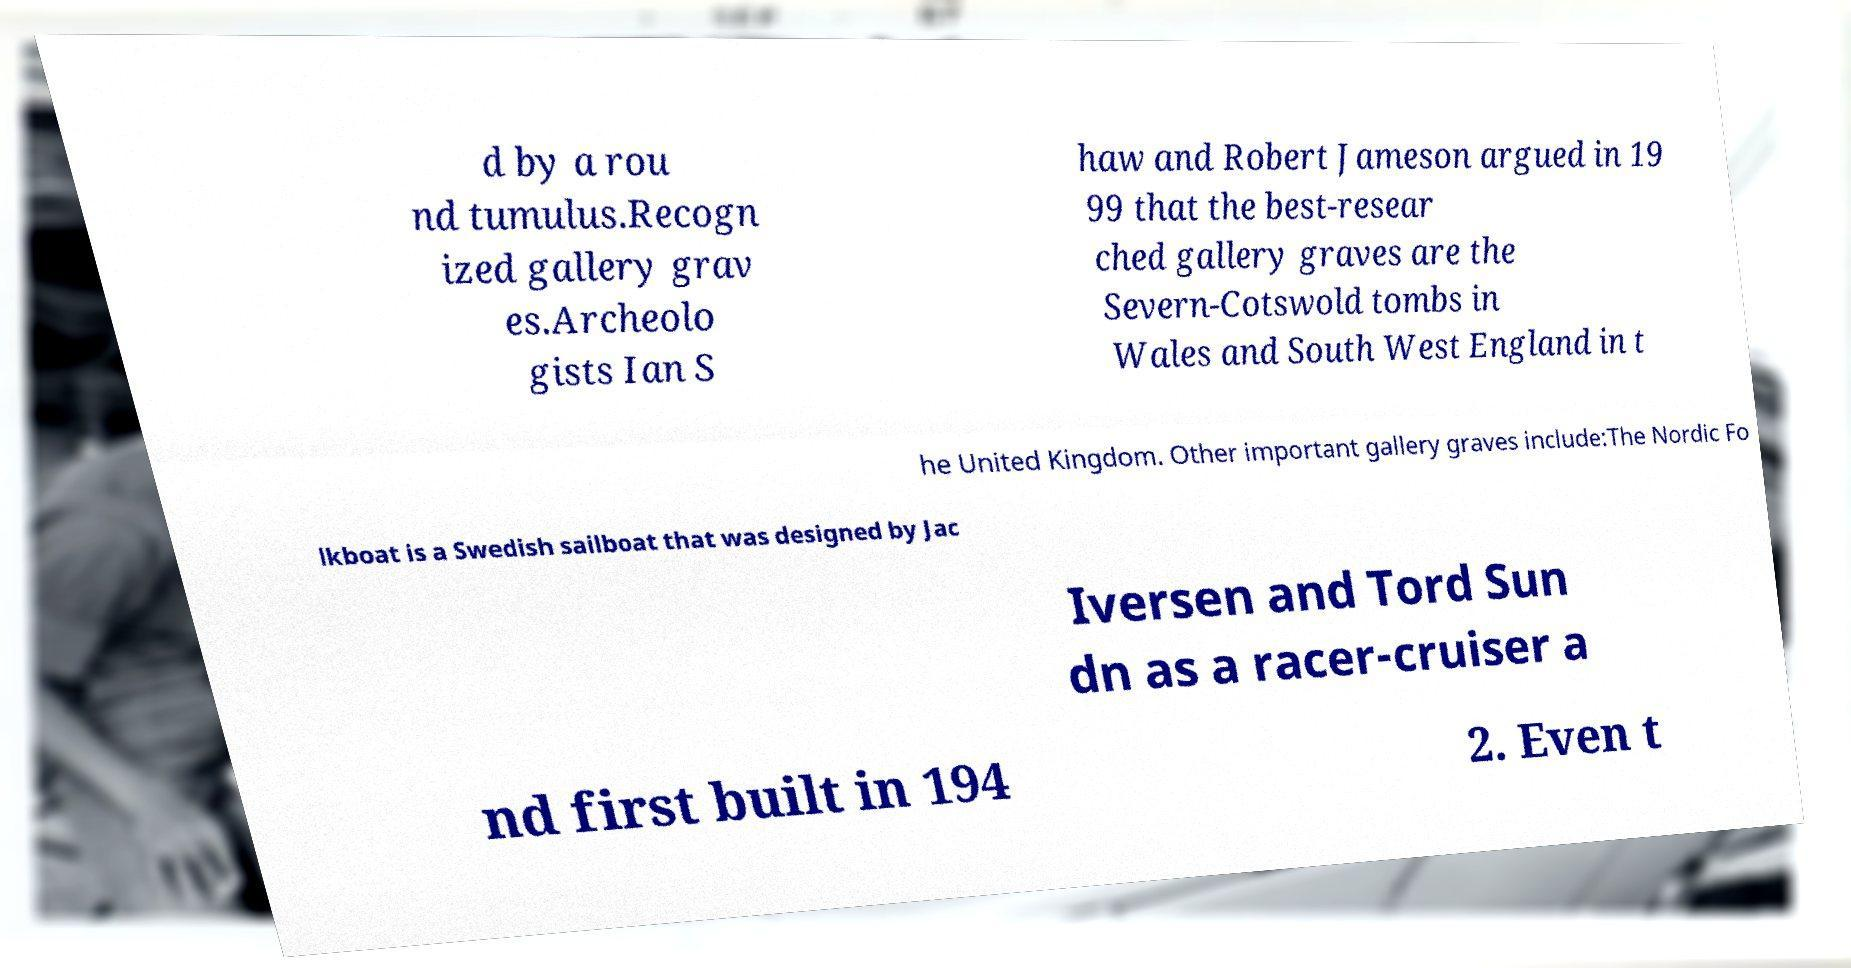Could you assist in decoding the text presented in this image and type it out clearly? d by a rou nd tumulus.Recogn ized gallery grav es.Archeolo gists Ian S haw and Robert Jameson argued in 19 99 that the best-resear ched gallery graves are the Severn-Cotswold tombs in Wales and South West England in t he United Kingdom. Other important gallery graves include:The Nordic Fo lkboat is a Swedish sailboat that was designed by Jac Iversen and Tord Sun dn as a racer-cruiser a nd first built in 194 2. Even t 